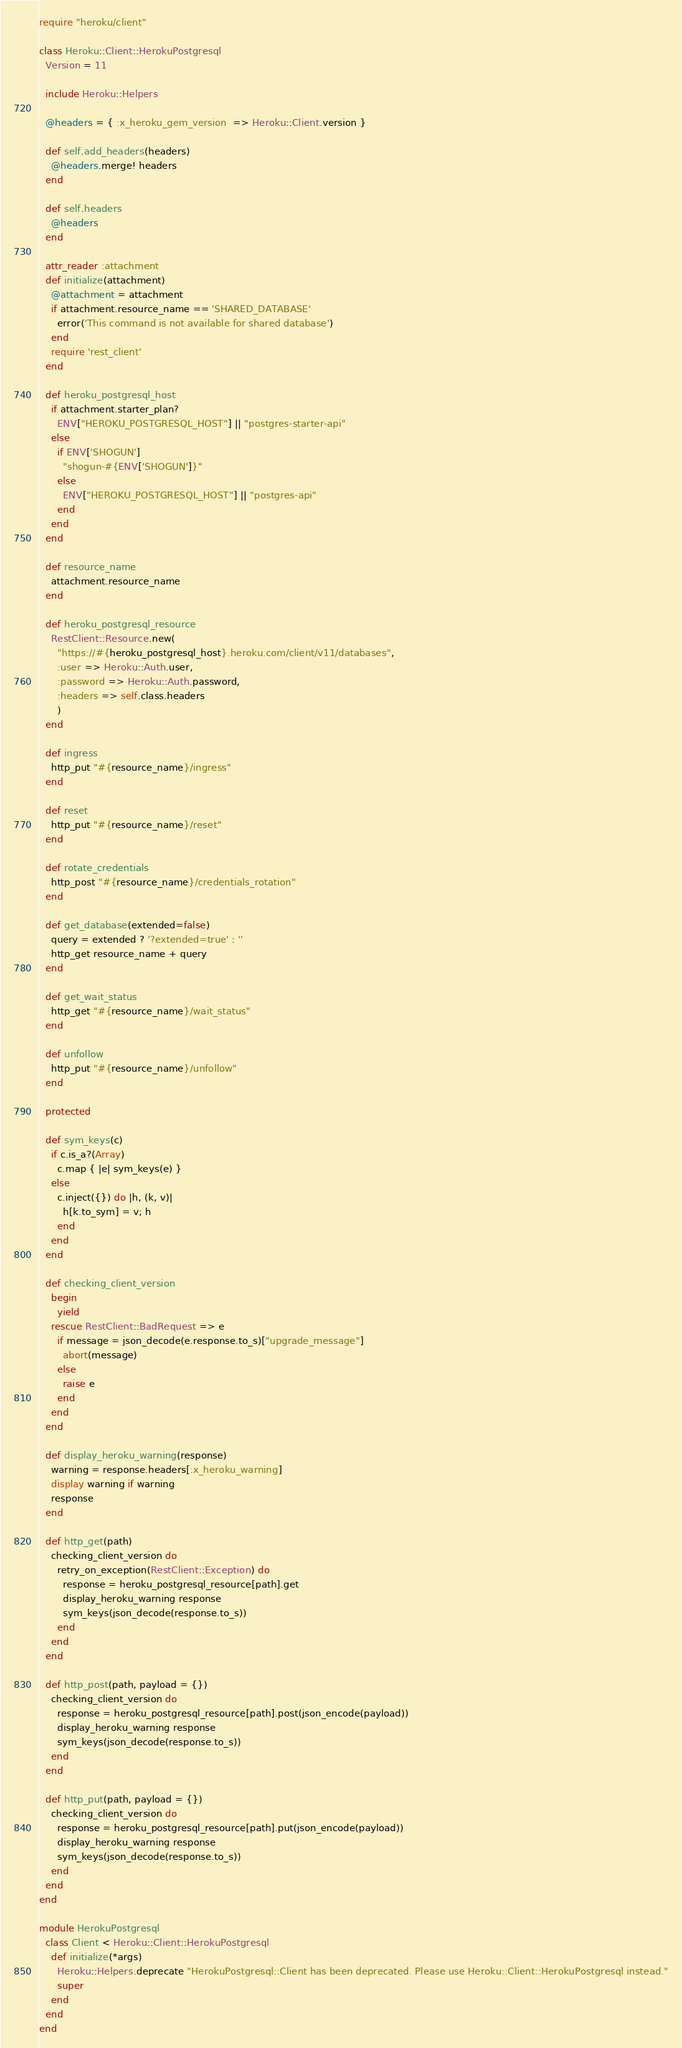<code> <loc_0><loc_0><loc_500><loc_500><_Ruby_>require "heroku/client"

class Heroku::Client::HerokuPostgresql
  Version = 11

  include Heroku::Helpers

  @headers = { :x_heroku_gem_version  => Heroku::Client.version }

  def self.add_headers(headers)
    @headers.merge! headers
  end

  def self.headers
    @headers
  end

  attr_reader :attachment
  def initialize(attachment)
    @attachment = attachment
    if attachment.resource_name == 'SHARED_DATABASE'
      error('This command is not available for shared database')
    end
    require 'rest_client'
  end

  def heroku_postgresql_host
    if attachment.starter_plan?
      ENV["HEROKU_POSTGRESQL_HOST"] || "postgres-starter-api"
    else
      if ENV['SHOGUN']
        "shogun-#{ENV['SHOGUN']}"
      else
        ENV["HEROKU_POSTGRESQL_HOST"] || "postgres-api"
      end
    end
  end

  def resource_name
    attachment.resource_name
  end

  def heroku_postgresql_resource
    RestClient::Resource.new(
      "https://#{heroku_postgresql_host}.heroku.com/client/v11/databases",
      :user => Heroku::Auth.user,
      :password => Heroku::Auth.password,
      :headers => self.class.headers
      )
  end

  def ingress
    http_put "#{resource_name}/ingress"
  end

  def reset
    http_put "#{resource_name}/reset"
  end

  def rotate_credentials
    http_post "#{resource_name}/credentials_rotation"
  end

  def get_database(extended=false)
    query = extended ? '?extended=true' : ''
    http_get resource_name + query
  end

  def get_wait_status
    http_get "#{resource_name}/wait_status"
  end

  def unfollow
    http_put "#{resource_name}/unfollow"
  end

  protected

  def sym_keys(c)
    if c.is_a?(Array)
      c.map { |e| sym_keys(e) }
    else
      c.inject({}) do |h, (k, v)|
        h[k.to_sym] = v; h
      end
    end
  end

  def checking_client_version
    begin
      yield
    rescue RestClient::BadRequest => e
      if message = json_decode(e.response.to_s)["upgrade_message"]
        abort(message)
      else
        raise e
      end
    end
  end

  def display_heroku_warning(response)
    warning = response.headers[:x_heroku_warning]
    display warning if warning
    response
  end

  def http_get(path)
    checking_client_version do
      retry_on_exception(RestClient::Exception) do
        response = heroku_postgresql_resource[path].get
        display_heroku_warning response
        sym_keys(json_decode(response.to_s))
      end
    end
  end

  def http_post(path, payload = {})
    checking_client_version do
      response = heroku_postgresql_resource[path].post(json_encode(payload))
      display_heroku_warning response
      sym_keys(json_decode(response.to_s))
    end
  end

  def http_put(path, payload = {})
    checking_client_version do
      response = heroku_postgresql_resource[path].put(json_encode(payload))
      display_heroku_warning response
      sym_keys(json_decode(response.to_s))
    end
  end
end

module HerokuPostgresql
  class Client < Heroku::Client::HerokuPostgresql
    def initialize(*args)
      Heroku::Helpers.deprecate "HerokuPostgresql::Client has been deprecated. Please use Heroku::Client::HerokuPostgresql instead."
      super
    end
  end
end
</code> 